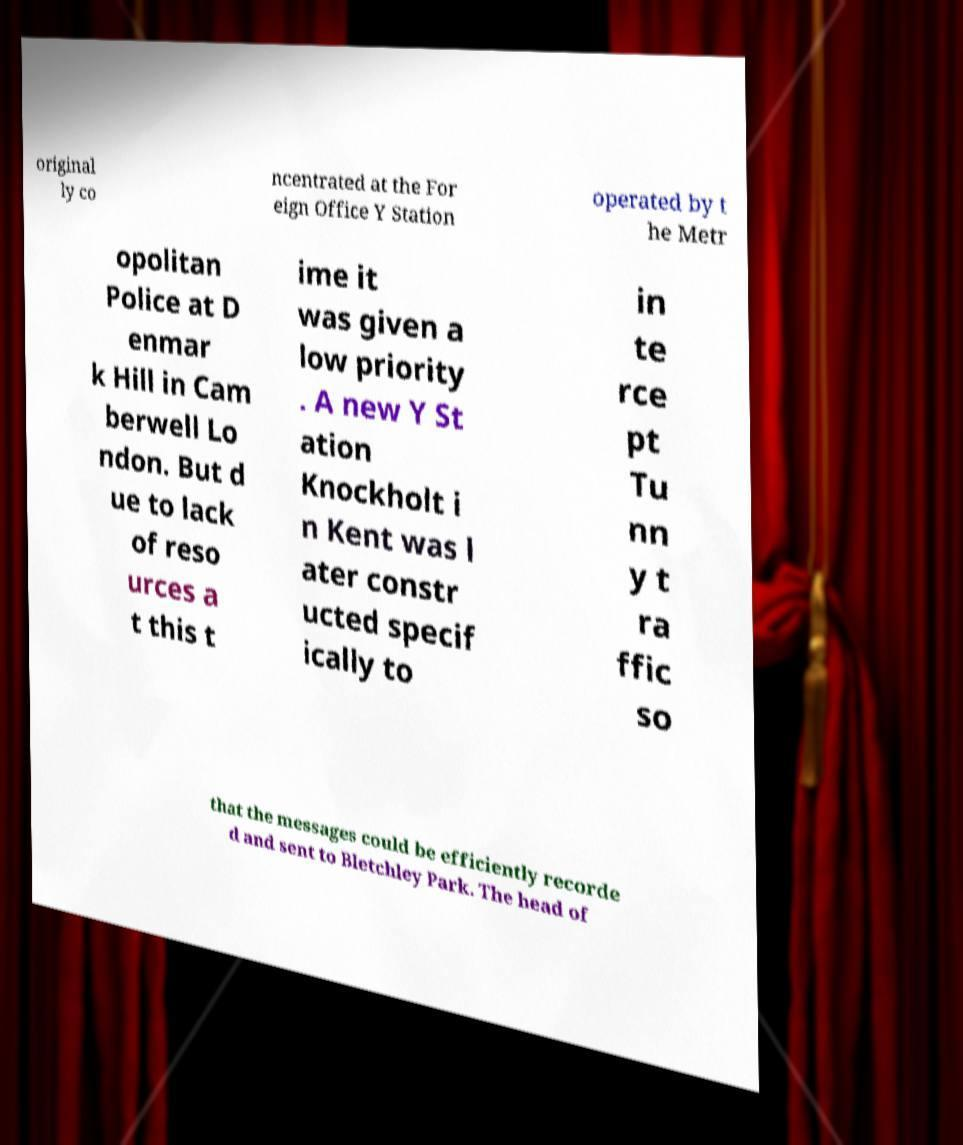Can you read and provide the text displayed in the image?This photo seems to have some interesting text. Can you extract and type it out for me? original ly co ncentrated at the For eign Office Y Station operated by t he Metr opolitan Police at D enmar k Hill in Cam berwell Lo ndon. But d ue to lack of reso urces a t this t ime it was given a low priority . A new Y St ation Knockholt i n Kent was l ater constr ucted specif ically to in te rce pt Tu nn y t ra ffic so that the messages could be efficiently recorde d and sent to Bletchley Park. The head of 